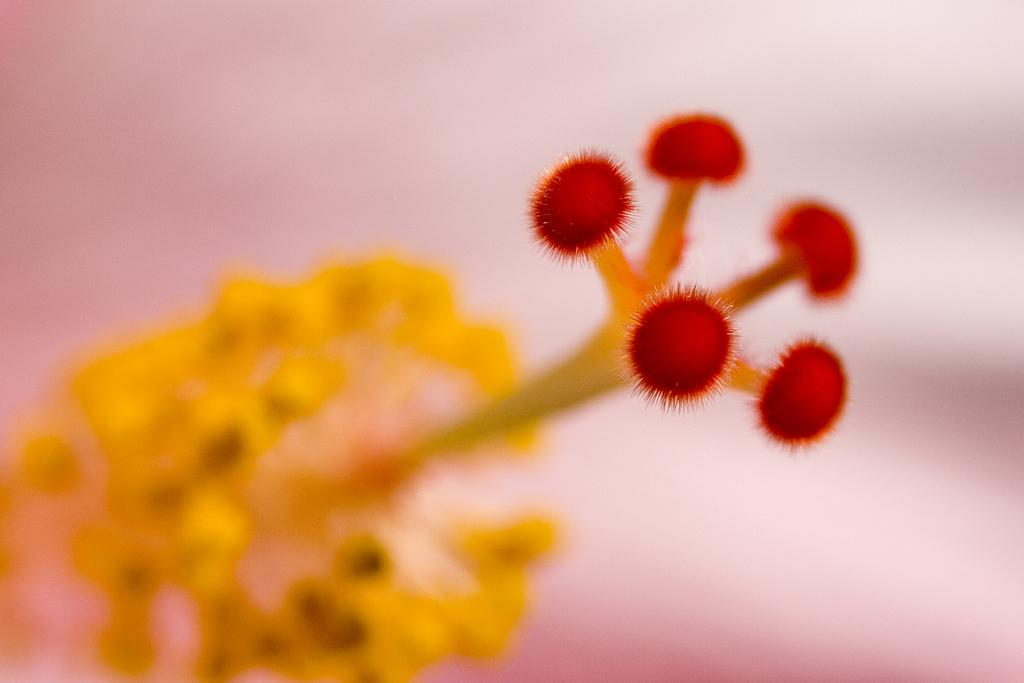What is the main subject of the image? There is a flower in the image. Can you describe the background of the image? The background of the image is blurred. How many loaves of bread can be seen in the garden in the image? There is no garden or loaves of bread present in the image; it features a flower with a blurred background. What type of owl is perched on the flower in the image? There is no owl present in the image; it features a flower with a blurred background. 